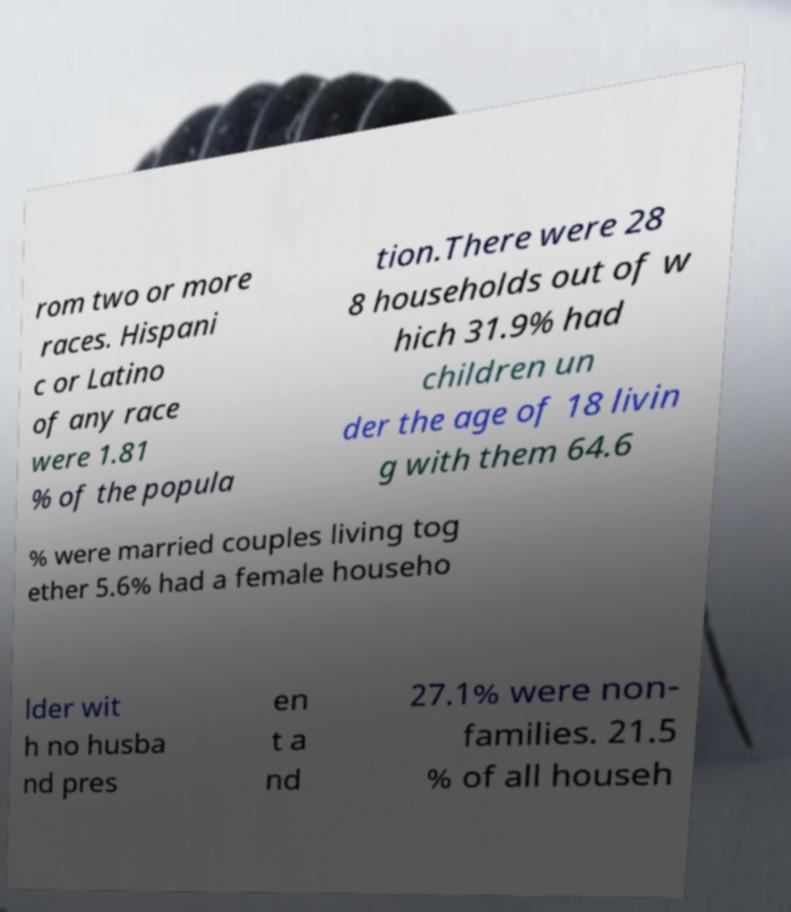Could you assist in decoding the text presented in this image and type it out clearly? rom two or more races. Hispani c or Latino of any race were 1.81 % of the popula tion.There were 28 8 households out of w hich 31.9% had children un der the age of 18 livin g with them 64.6 % were married couples living tog ether 5.6% had a female househo lder wit h no husba nd pres en t a nd 27.1% were non- families. 21.5 % of all househ 